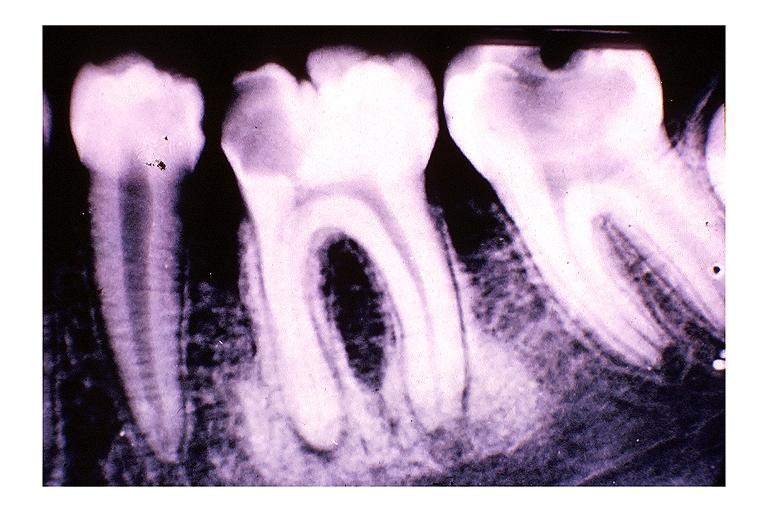what is present?
Answer the question using a single word or phrase. Oral 